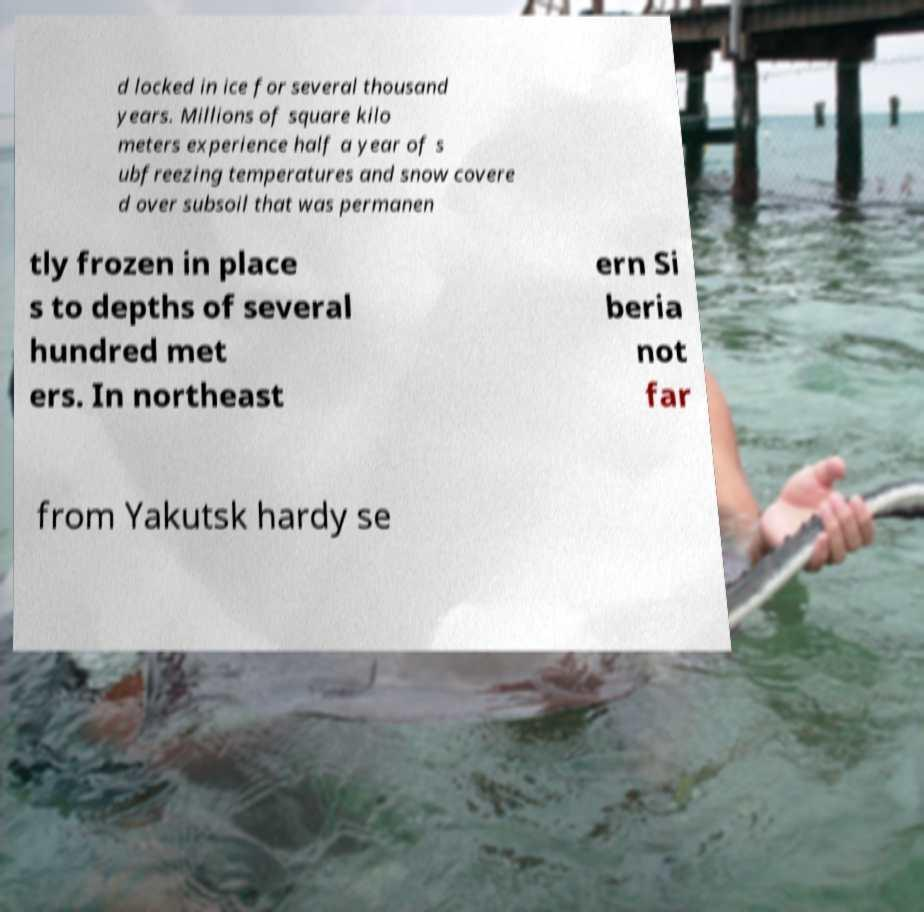For documentation purposes, I need the text within this image transcribed. Could you provide that? d locked in ice for several thousand years. Millions of square kilo meters experience half a year of s ubfreezing temperatures and snow covere d over subsoil that was permanen tly frozen in place s to depths of several hundred met ers. In northeast ern Si beria not far from Yakutsk hardy se 